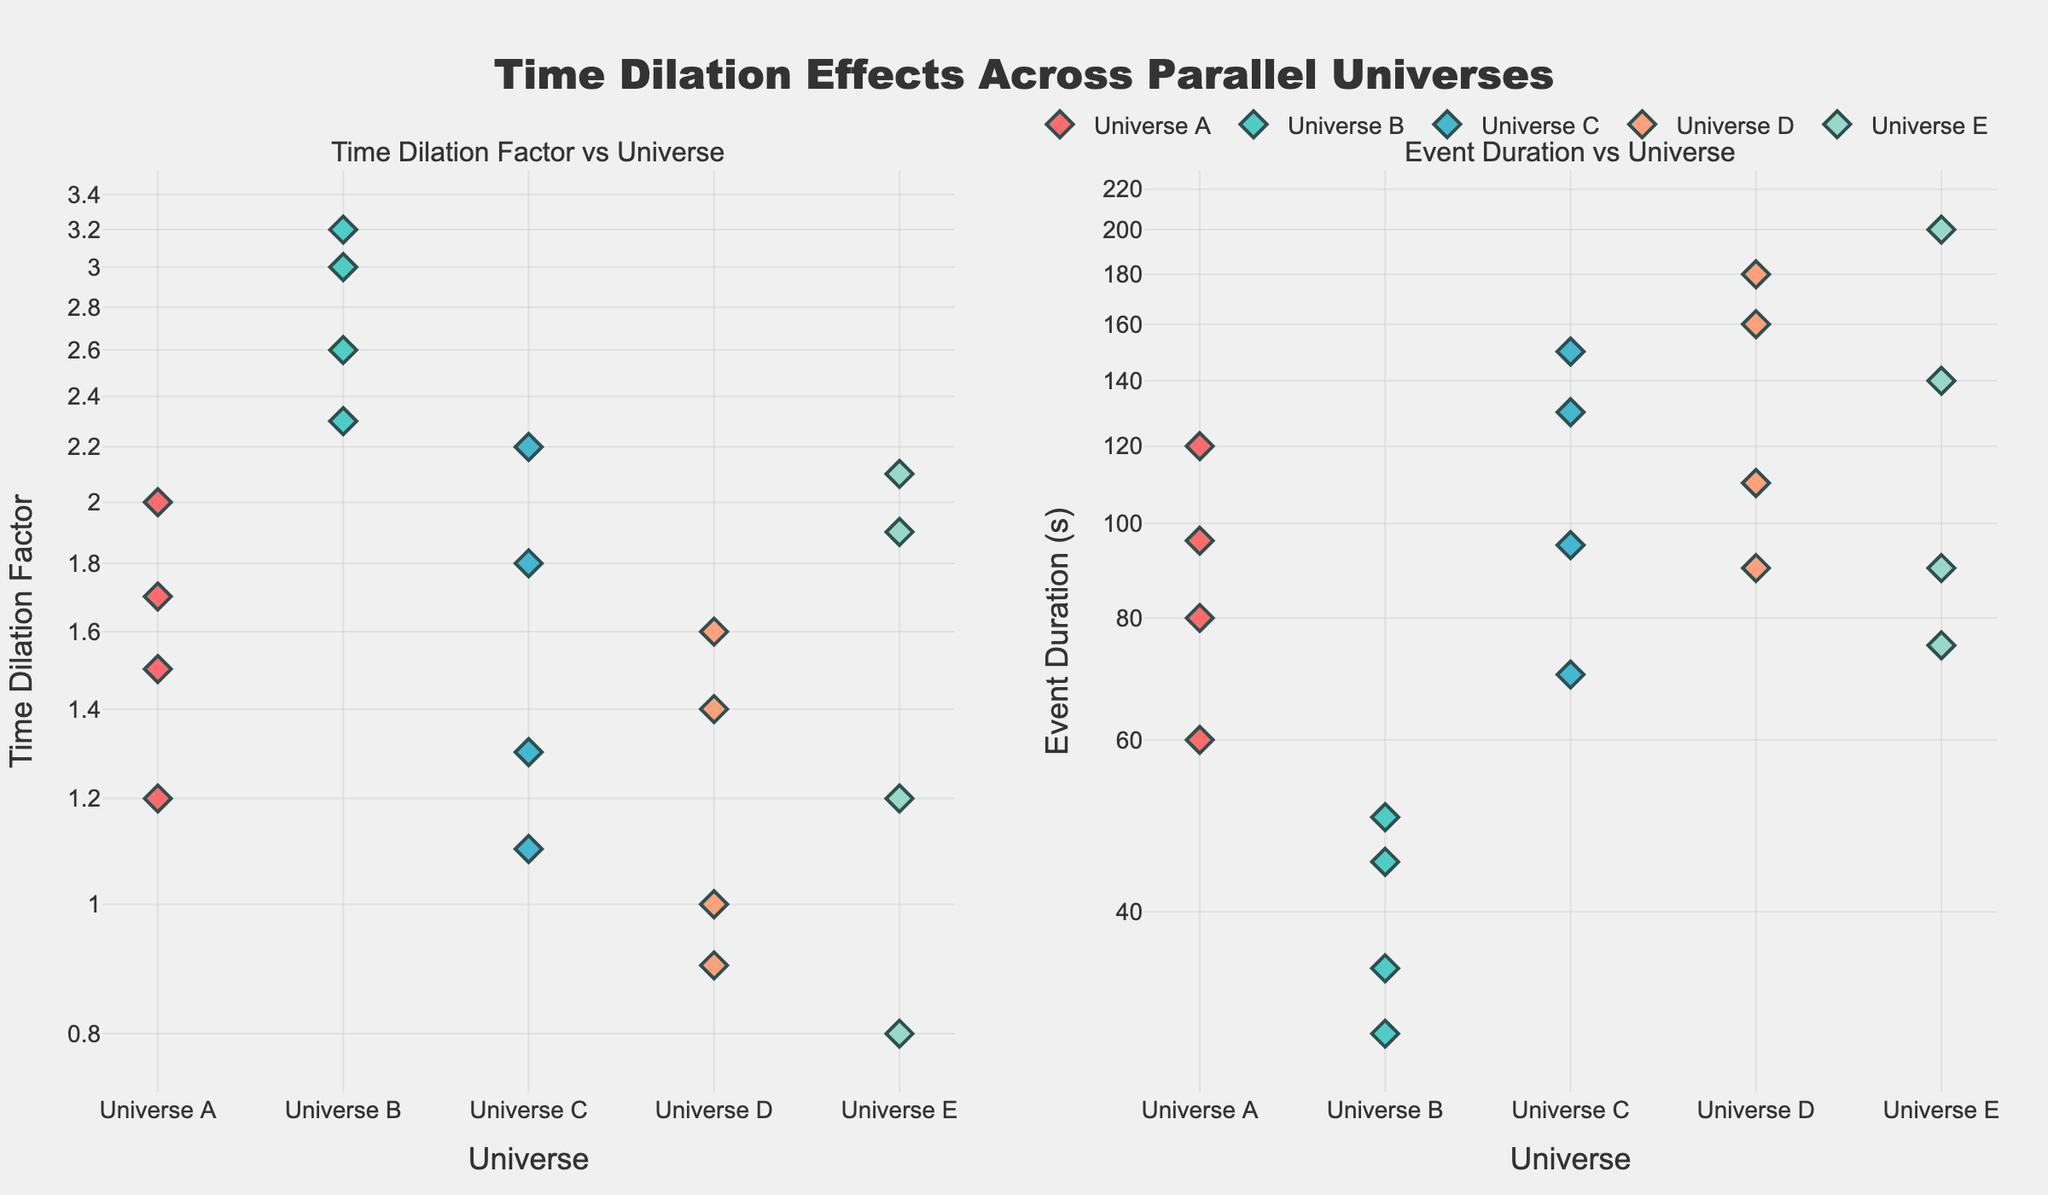What is the title of the figure? The title is positioned at the top center of the figure. It states, "Time Dilation Effects Across Parallel Universes".
Answer: Time Dilation Effects Across Parallel Universes What are the units on the y-axis of the right subplot? The y-axis on the right subplot represents "Event Duration (s)", indicating the duration of events in seconds.
Answer: Event Duration (s) Which universe has the highest Time Dilation Factor? The subplot on the left displays the Time Dilation Factor for different universes. Universe B has the highest Time Dilation Factor at 3.2.
Answer: Universe B How many data points are plotted for Universe C? Counting the number of markers (diamonds) corresponding to Universe C in either subplot reveals there are 4 data points.
Answer: 4 In which universe does the longest event duration occur? Looking at the right subplot, the highest point on the y-axis is the event duration for Universe E, which is 200 seconds.
Answer: Universe E Compare the median Time Dilation Factors of Universe A and Universe B. Which one is higher? The Time Dilation Factors for Universe A are 1.2, 1.5, 1.7, and 2.0. The median of these values is 1.6. For Universe B, they are 2.3, 2.6, 3.0, and 3.2, with a median of 2.8. Comparing these medians, Universe B has a higher median Time Dilation Factor.
Answer: Universe B What is the difference between the highest and lowest Event Durations across all universes? The right subplot shows that the highest Event Duration is 200 seconds (Universe E), and the lowest is 30 seconds (Universe B). The difference is calculated as 200 - 30 = 170 seconds.
Answer: 170 seconds Which universe has the most significant range in Time Dilation Factors? By examining the range of points in the left subplot, Universe B spans from 2.3 to 3.2, which gives a range of 3.2 - 2.3 = 0.9. Comparatively, other universes have smaller ranges within their respective data points.
Answer: Universe B Describe the trend of Time Dilation Factors for Universe D and how it impacts Event Duration. For Universe D (left subplot), the Time Dilation Factors increase from 0.9 to 1.6. Correspondingly, Event Durations (right subplot) decrease from 180 seconds to 90 seconds. This inverse relationship means as the Time Dilation Factor increases, the Event Duration decreases.
Answer: As Time Dilation Factor increases, Event Duration decreases 